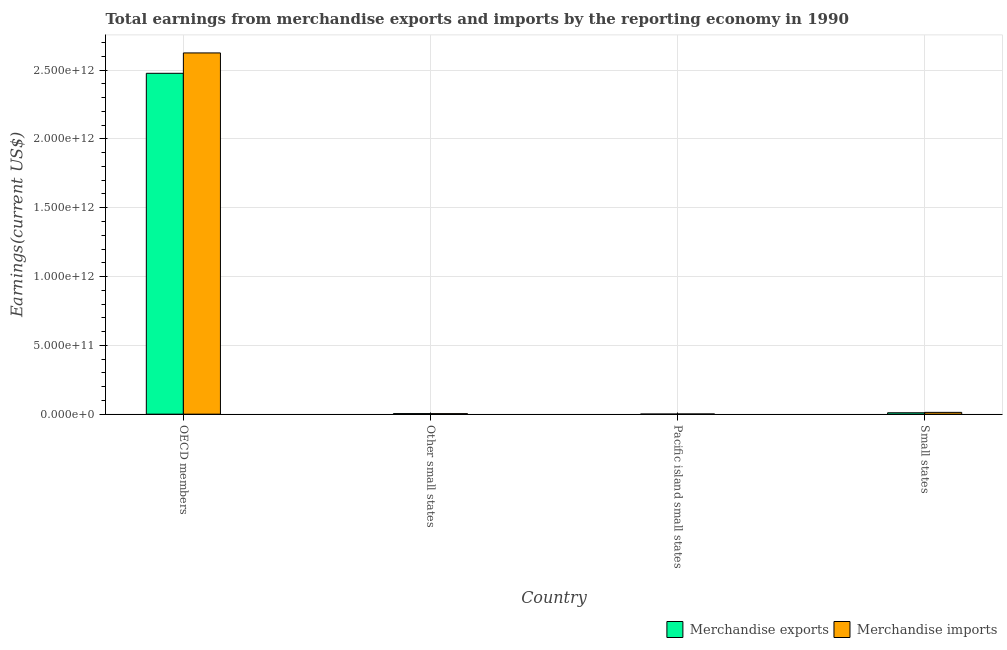How many different coloured bars are there?
Provide a succinct answer. 2. How many groups of bars are there?
Your answer should be very brief. 4. Are the number of bars per tick equal to the number of legend labels?
Your response must be concise. Yes. How many bars are there on the 1st tick from the right?
Your answer should be compact. 2. What is the label of the 4th group of bars from the left?
Your response must be concise. Small states. What is the earnings from merchandise exports in Other small states?
Give a very brief answer. 4.09e+09. Across all countries, what is the maximum earnings from merchandise imports?
Offer a terse response. 2.62e+12. Across all countries, what is the minimum earnings from merchandise exports?
Offer a terse response. 6.27e+08. In which country was the earnings from merchandise exports maximum?
Provide a short and direct response. OECD members. In which country was the earnings from merchandise imports minimum?
Offer a terse response. Pacific island small states. What is the total earnings from merchandise imports in the graph?
Your answer should be very brief. 2.64e+12. What is the difference between the earnings from merchandise exports in OECD members and that in Small states?
Provide a succinct answer. 2.47e+12. What is the difference between the earnings from merchandise imports in Pacific island small states and the earnings from merchandise exports in OECD members?
Provide a succinct answer. -2.48e+12. What is the average earnings from merchandise exports per country?
Your answer should be compact. 6.23e+11. What is the difference between the earnings from merchandise imports and earnings from merchandise exports in Small states?
Keep it short and to the point. 2.81e+09. In how many countries, is the earnings from merchandise exports greater than 2400000000000 US$?
Your answer should be compact. 1. What is the ratio of the earnings from merchandise exports in Other small states to that in Small states?
Offer a very short reply. 0.4. Is the earnings from merchandise exports in OECD members less than that in Small states?
Keep it short and to the point. No. Is the difference between the earnings from merchandise imports in Other small states and Small states greater than the difference between the earnings from merchandise exports in Other small states and Small states?
Your answer should be very brief. No. What is the difference between the highest and the second highest earnings from merchandise imports?
Provide a short and direct response. 2.61e+12. What is the difference between the highest and the lowest earnings from merchandise imports?
Your answer should be compact. 2.62e+12. What does the 1st bar from the right in Other small states represents?
Offer a terse response. Merchandise imports. Are all the bars in the graph horizontal?
Your response must be concise. No. What is the difference between two consecutive major ticks on the Y-axis?
Give a very brief answer. 5.00e+11. Are the values on the major ticks of Y-axis written in scientific E-notation?
Provide a succinct answer. Yes. What is the title of the graph?
Provide a succinct answer. Total earnings from merchandise exports and imports by the reporting economy in 1990. What is the label or title of the Y-axis?
Keep it short and to the point. Earnings(current US$). What is the Earnings(current US$) of Merchandise exports in OECD members?
Provide a short and direct response. 2.48e+12. What is the Earnings(current US$) of Merchandise imports in OECD members?
Make the answer very short. 2.62e+12. What is the Earnings(current US$) of Merchandise exports in Other small states?
Your answer should be very brief. 4.09e+09. What is the Earnings(current US$) of Merchandise imports in Other small states?
Make the answer very short. 3.74e+09. What is the Earnings(current US$) of Merchandise exports in Pacific island small states?
Make the answer very short. 6.27e+08. What is the Earnings(current US$) of Merchandise imports in Pacific island small states?
Provide a succinct answer. 1.35e+09. What is the Earnings(current US$) in Merchandise exports in Small states?
Your answer should be compact. 1.02e+1. What is the Earnings(current US$) in Merchandise imports in Small states?
Your answer should be compact. 1.30e+1. Across all countries, what is the maximum Earnings(current US$) in Merchandise exports?
Keep it short and to the point. 2.48e+12. Across all countries, what is the maximum Earnings(current US$) of Merchandise imports?
Your response must be concise. 2.62e+12. Across all countries, what is the minimum Earnings(current US$) in Merchandise exports?
Ensure brevity in your answer.  6.27e+08. Across all countries, what is the minimum Earnings(current US$) in Merchandise imports?
Keep it short and to the point. 1.35e+09. What is the total Earnings(current US$) of Merchandise exports in the graph?
Your answer should be very brief. 2.49e+12. What is the total Earnings(current US$) in Merchandise imports in the graph?
Your answer should be very brief. 2.64e+12. What is the difference between the Earnings(current US$) of Merchandise exports in OECD members and that in Other small states?
Your answer should be compact. 2.47e+12. What is the difference between the Earnings(current US$) of Merchandise imports in OECD members and that in Other small states?
Offer a very short reply. 2.62e+12. What is the difference between the Earnings(current US$) of Merchandise exports in OECD members and that in Pacific island small states?
Your answer should be very brief. 2.48e+12. What is the difference between the Earnings(current US$) of Merchandise imports in OECD members and that in Pacific island small states?
Ensure brevity in your answer.  2.62e+12. What is the difference between the Earnings(current US$) of Merchandise exports in OECD members and that in Small states?
Your answer should be very brief. 2.47e+12. What is the difference between the Earnings(current US$) in Merchandise imports in OECD members and that in Small states?
Offer a very short reply. 2.61e+12. What is the difference between the Earnings(current US$) of Merchandise exports in Other small states and that in Pacific island small states?
Give a very brief answer. 3.46e+09. What is the difference between the Earnings(current US$) of Merchandise imports in Other small states and that in Pacific island small states?
Your answer should be very brief. 2.39e+09. What is the difference between the Earnings(current US$) of Merchandise exports in Other small states and that in Small states?
Provide a succinct answer. -6.12e+09. What is the difference between the Earnings(current US$) of Merchandise imports in Other small states and that in Small states?
Make the answer very short. -9.28e+09. What is the difference between the Earnings(current US$) of Merchandise exports in Pacific island small states and that in Small states?
Make the answer very short. -9.59e+09. What is the difference between the Earnings(current US$) in Merchandise imports in Pacific island small states and that in Small states?
Offer a terse response. -1.17e+1. What is the difference between the Earnings(current US$) of Merchandise exports in OECD members and the Earnings(current US$) of Merchandise imports in Other small states?
Offer a very short reply. 2.47e+12. What is the difference between the Earnings(current US$) in Merchandise exports in OECD members and the Earnings(current US$) in Merchandise imports in Pacific island small states?
Your answer should be compact. 2.48e+12. What is the difference between the Earnings(current US$) in Merchandise exports in OECD members and the Earnings(current US$) in Merchandise imports in Small states?
Offer a very short reply. 2.46e+12. What is the difference between the Earnings(current US$) of Merchandise exports in Other small states and the Earnings(current US$) of Merchandise imports in Pacific island small states?
Offer a very short reply. 2.73e+09. What is the difference between the Earnings(current US$) of Merchandise exports in Other small states and the Earnings(current US$) of Merchandise imports in Small states?
Provide a short and direct response. -8.94e+09. What is the difference between the Earnings(current US$) in Merchandise exports in Pacific island small states and the Earnings(current US$) in Merchandise imports in Small states?
Make the answer very short. -1.24e+1. What is the average Earnings(current US$) in Merchandise exports per country?
Keep it short and to the point. 6.23e+11. What is the average Earnings(current US$) of Merchandise imports per country?
Offer a very short reply. 6.61e+11. What is the difference between the Earnings(current US$) of Merchandise exports and Earnings(current US$) of Merchandise imports in OECD members?
Your answer should be compact. -1.48e+11. What is the difference between the Earnings(current US$) in Merchandise exports and Earnings(current US$) in Merchandise imports in Other small states?
Offer a terse response. 3.46e+08. What is the difference between the Earnings(current US$) in Merchandise exports and Earnings(current US$) in Merchandise imports in Pacific island small states?
Make the answer very short. -7.27e+08. What is the difference between the Earnings(current US$) of Merchandise exports and Earnings(current US$) of Merchandise imports in Small states?
Give a very brief answer. -2.81e+09. What is the ratio of the Earnings(current US$) in Merchandise exports in OECD members to that in Other small states?
Keep it short and to the point. 605.91. What is the ratio of the Earnings(current US$) of Merchandise imports in OECD members to that in Other small states?
Your response must be concise. 701.51. What is the ratio of the Earnings(current US$) of Merchandise exports in OECD members to that in Pacific island small states?
Offer a very short reply. 3952.62. What is the ratio of the Earnings(current US$) in Merchandise imports in OECD members to that in Pacific island small states?
Ensure brevity in your answer.  1939.27. What is the ratio of the Earnings(current US$) in Merchandise exports in OECD members to that in Small states?
Make the answer very short. 242.55. What is the ratio of the Earnings(current US$) of Merchandise imports in OECD members to that in Small states?
Give a very brief answer. 201.54. What is the ratio of the Earnings(current US$) of Merchandise exports in Other small states to that in Pacific island small states?
Give a very brief answer. 6.52. What is the ratio of the Earnings(current US$) of Merchandise imports in Other small states to that in Pacific island small states?
Provide a short and direct response. 2.76. What is the ratio of the Earnings(current US$) of Merchandise exports in Other small states to that in Small states?
Your answer should be very brief. 0.4. What is the ratio of the Earnings(current US$) of Merchandise imports in Other small states to that in Small states?
Keep it short and to the point. 0.29. What is the ratio of the Earnings(current US$) of Merchandise exports in Pacific island small states to that in Small states?
Your answer should be very brief. 0.06. What is the ratio of the Earnings(current US$) of Merchandise imports in Pacific island small states to that in Small states?
Offer a very short reply. 0.1. What is the difference between the highest and the second highest Earnings(current US$) in Merchandise exports?
Keep it short and to the point. 2.47e+12. What is the difference between the highest and the second highest Earnings(current US$) of Merchandise imports?
Give a very brief answer. 2.61e+12. What is the difference between the highest and the lowest Earnings(current US$) in Merchandise exports?
Your answer should be compact. 2.48e+12. What is the difference between the highest and the lowest Earnings(current US$) in Merchandise imports?
Your answer should be compact. 2.62e+12. 